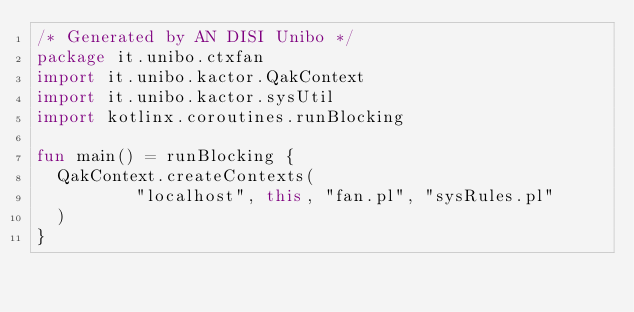<code> <loc_0><loc_0><loc_500><loc_500><_Kotlin_>/* Generated by AN DISI Unibo */ 
package it.unibo.ctxfan
import it.unibo.kactor.QakContext
import it.unibo.kactor.sysUtil
import kotlinx.coroutines.runBlocking

fun main() = runBlocking {
	QakContext.createContexts(
	        "localhost", this, "fan.pl", "sysRules.pl"
	)
}

</code> 